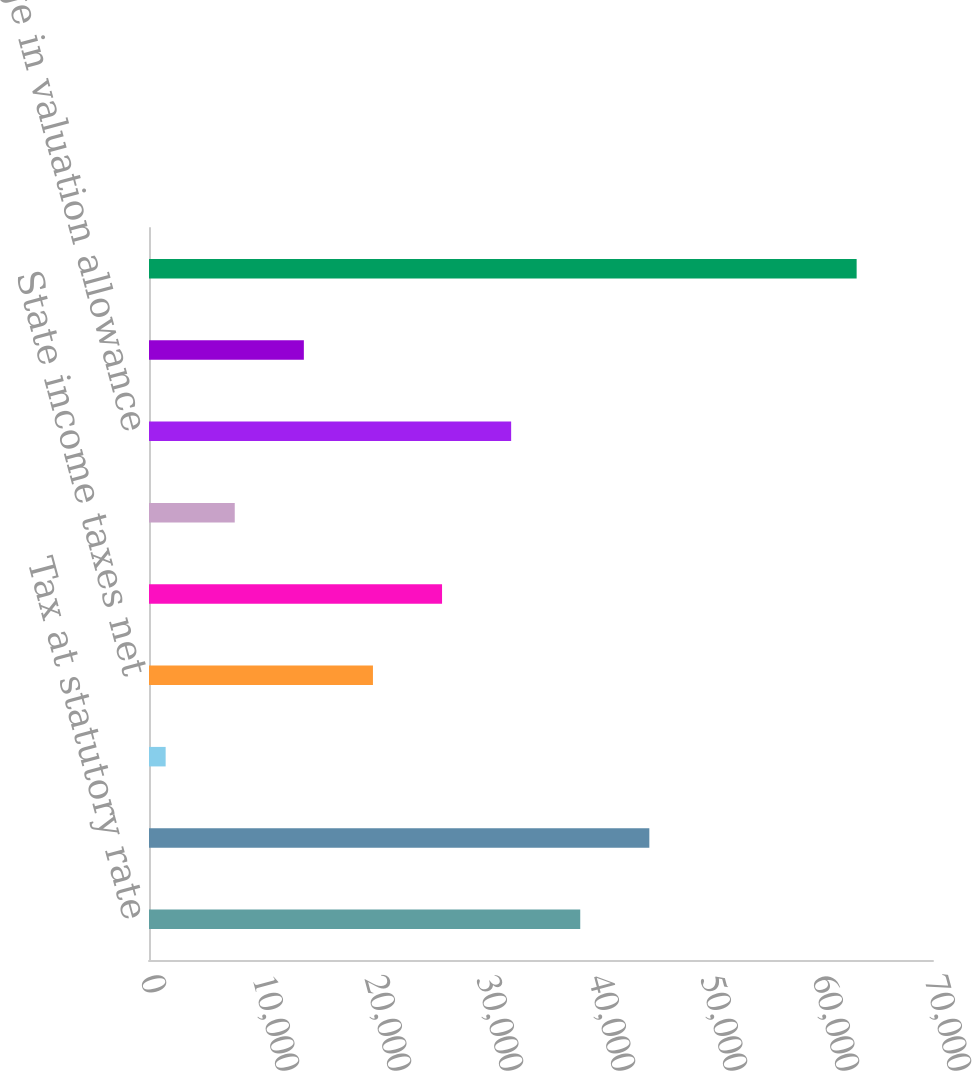<chart> <loc_0><loc_0><loc_500><loc_500><bar_chart><fcel>Tax at statutory rate<fcel>Non-US rate differential net<fcel>US taxation of multinational<fcel>State income taxes net<fcel>Prior year tax matters<fcel>Federal tax credits<fcel>Change in valuation allowance<fcel>Other net<fcel>Total<nl><fcel>38504<fcel>44673.5<fcel>1487<fcel>19995.5<fcel>26165<fcel>7656.5<fcel>32334.5<fcel>13826<fcel>63182<nl></chart> 